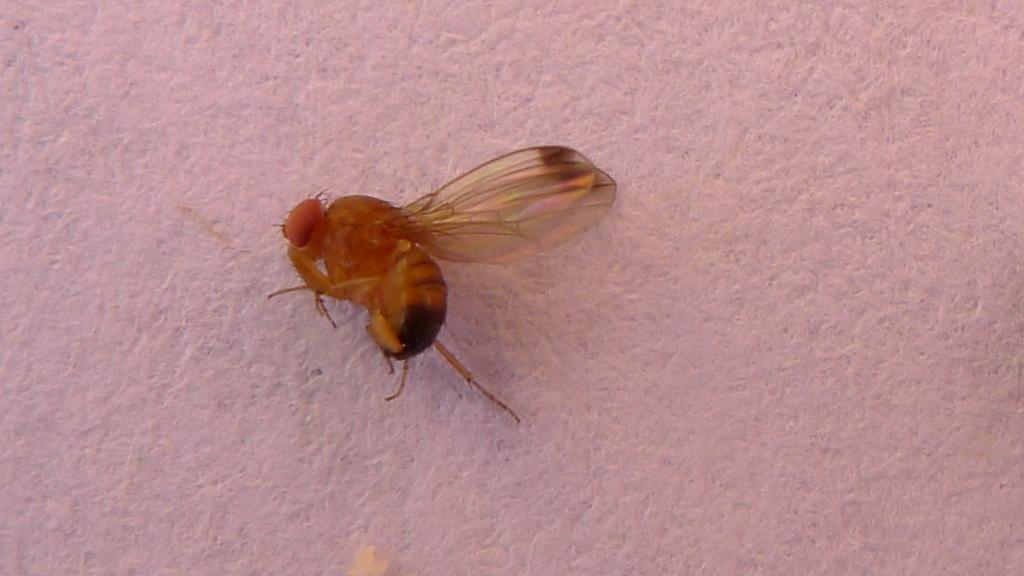What type of creature is present in the image? There is an insect in the image. What colors can be seen on the insect? The insect has brown and black colors. What is the color of the background in the image? The background of the image is white. Where is the basketball court located in the image? There is no basketball court present in the image; it features an insect with brown and black colors against a white background. How many swings can be seen in the field in the image? There is no field or swings present in the image; it features an insect with brown and black colors against a white background. 